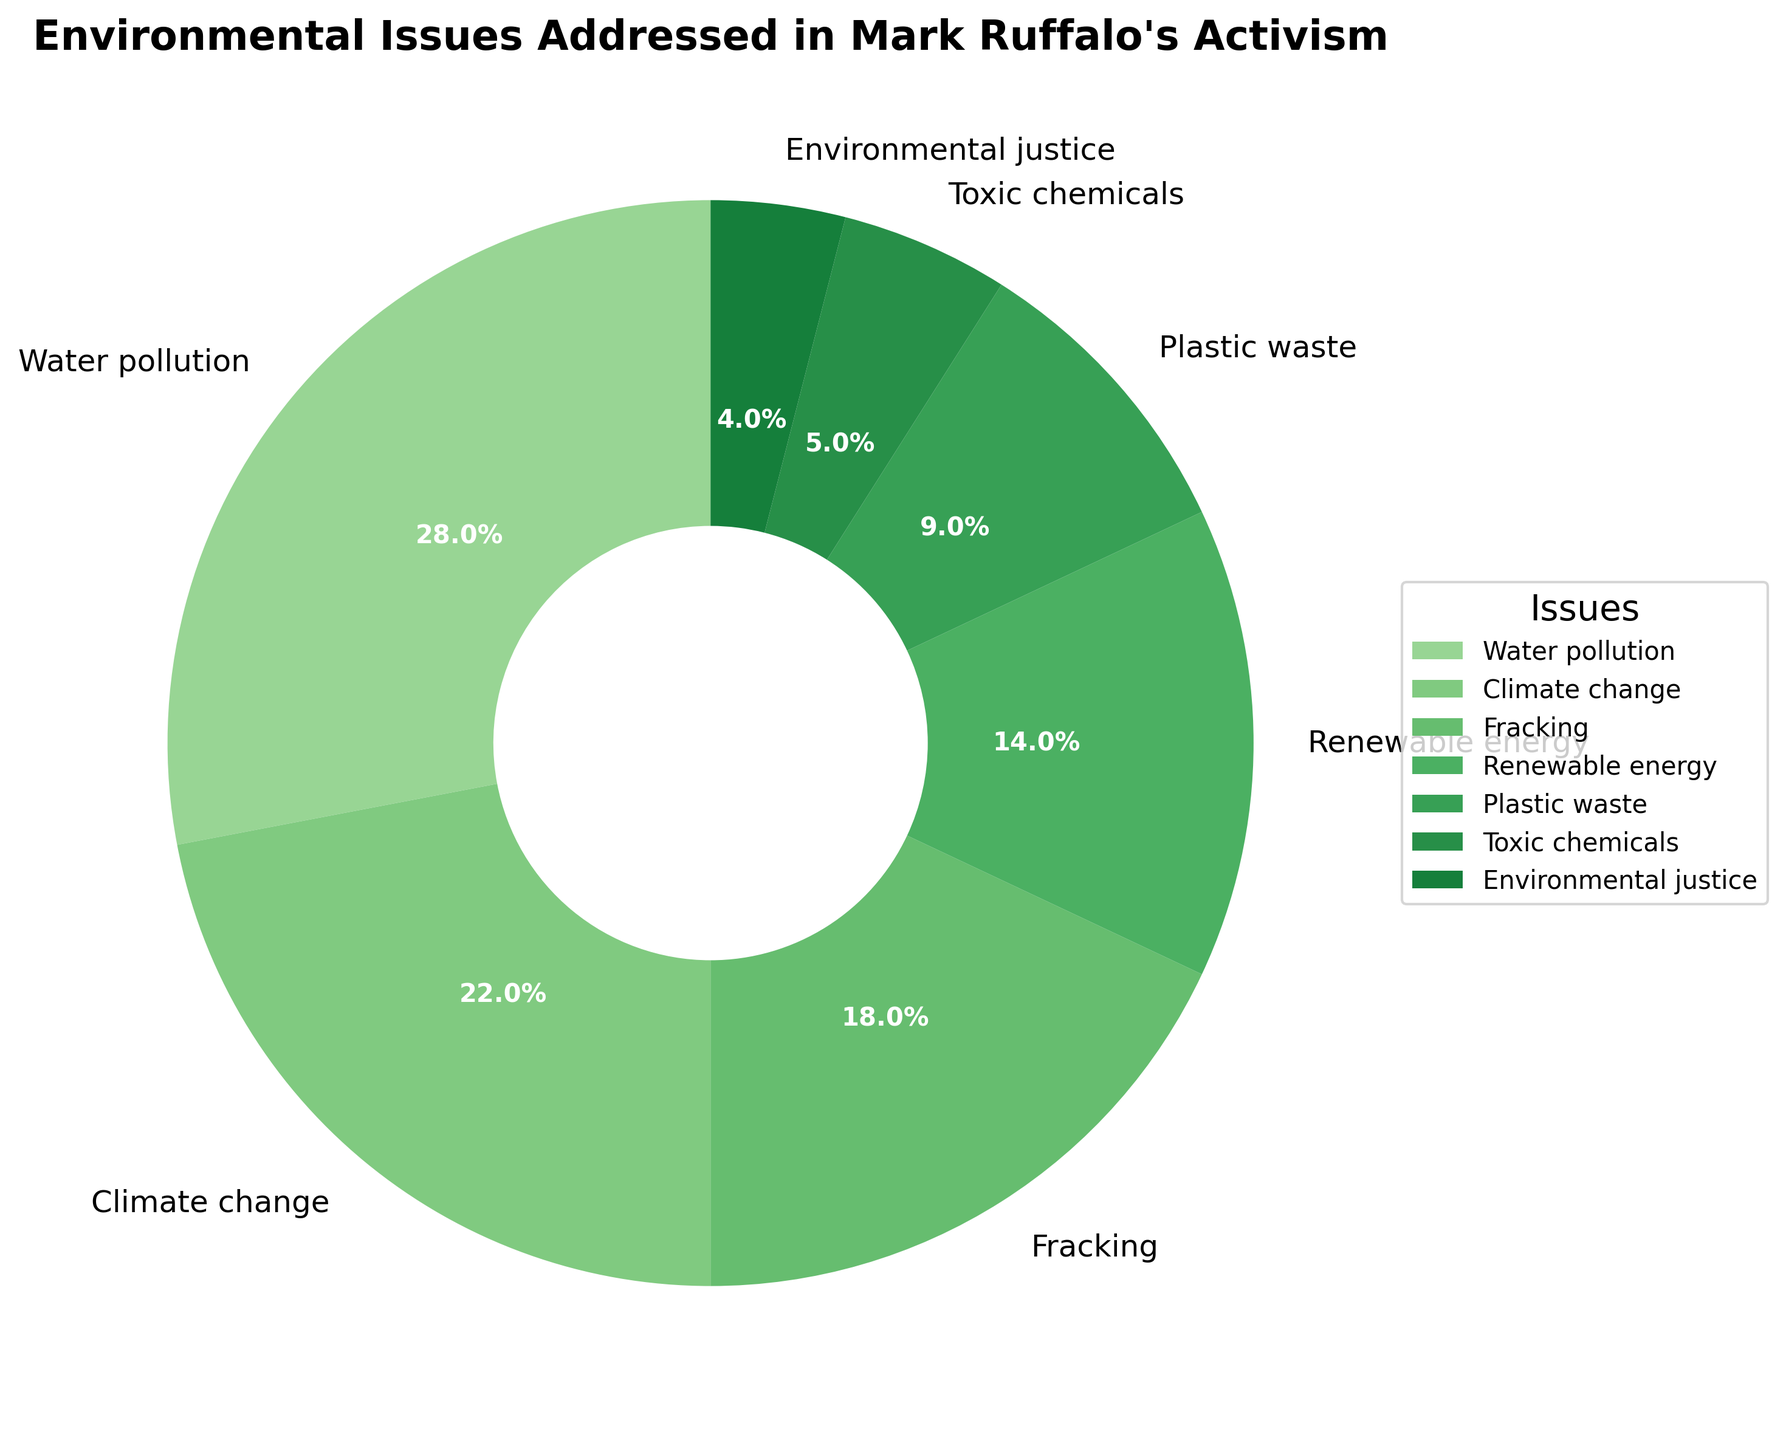Which environmental issue addressed by Mark Ruffalo's activism has the highest percentage? The figure shows a pie chart with percentages. The issue with the highest percentage can be identified by locating the largest segment.
Answer: Water pollution What is the combined percentage for Climate change and Fracking? Look at the segments for Climate change and Fracking, and add their percentages: 22% + 18%.
Answer: 40% How many percentage points less is Toxic chemicals compared to Plastic waste? Find the percentages for Toxic chemicals and Plastic waste, then subtract the former from the latter: 9% - 5%.
Answer: 4% Which issue has the smallest representation in the pie chart? Identify the smallest segment in the pie chart, which represents the issue with the smallest percentage.
Answer: Environmental justice What is the total percentage of issues related to pollution (Water pollution and Plastic waste)? Add the percentages of issues directly related to pollution: Water pollution (28%) + Plastic waste (9%).
Answer: 37% Are there more issues related to Fracking or Renewable energy in Mark Ruffalo's activism? Compare the segments for Fracking and Renewable energy by looking at their percentages: Fracking (18%), Renewable energy (14%).
Answer: Fracking If new data showed Toxic chemicals rising to 10%, what would happen to the total percentage represented by the other issues? If Toxic chemicals rises to 10%, it gains 5%, which must be taken from other issues. Therefore, the total percentage for the other issues would decrease by 5%.
Answer: Decrease by 5% What is the average percentage for Climate change, Renewable energy, and Plastic waste? Add the percentages for these issues and divide by the number of issues: (22% + 14% + 9%) / 3
Answer: 15% What percentage of the environmental issues does Water pollution represent compared to Toxic chemicals and Environmental justice combined? Compare the percentage for Water pollution (28%) to the sum of Toxic chemicals (5%) and Environmental justice (4%): 28% vs 9%.
Answer: Water pollution is greater by 19% How does the percentage of Climate change compare visually to Plastic waste on the pie chart? Observe the segments for Climate change and Plastic waste and compare their sizes visually. Climate change has a larger segment compared to Plastic waste.
Answer: Climate change is larger 